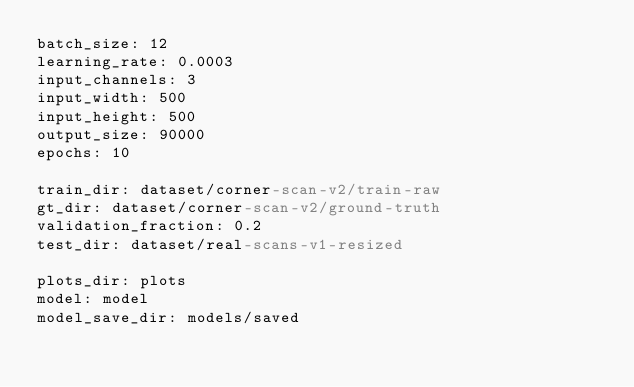Convert code to text. <code><loc_0><loc_0><loc_500><loc_500><_YAML_>batch_size: 12
learning_rate: 0.0003
input_channels: 3
input_width: 500
input_height: 500
output_size: 90000
epochs: 10

train_dir: dataset/corner-scan-v2/train-raw
gt_dir: dataset/corner-scan-v2/ground-truth
validation_fraction: 0.2
test_dir: dataset/real-scans-v1-resized

plots_dir: plots
model: model
model_save_dir: models/saved

</code> 